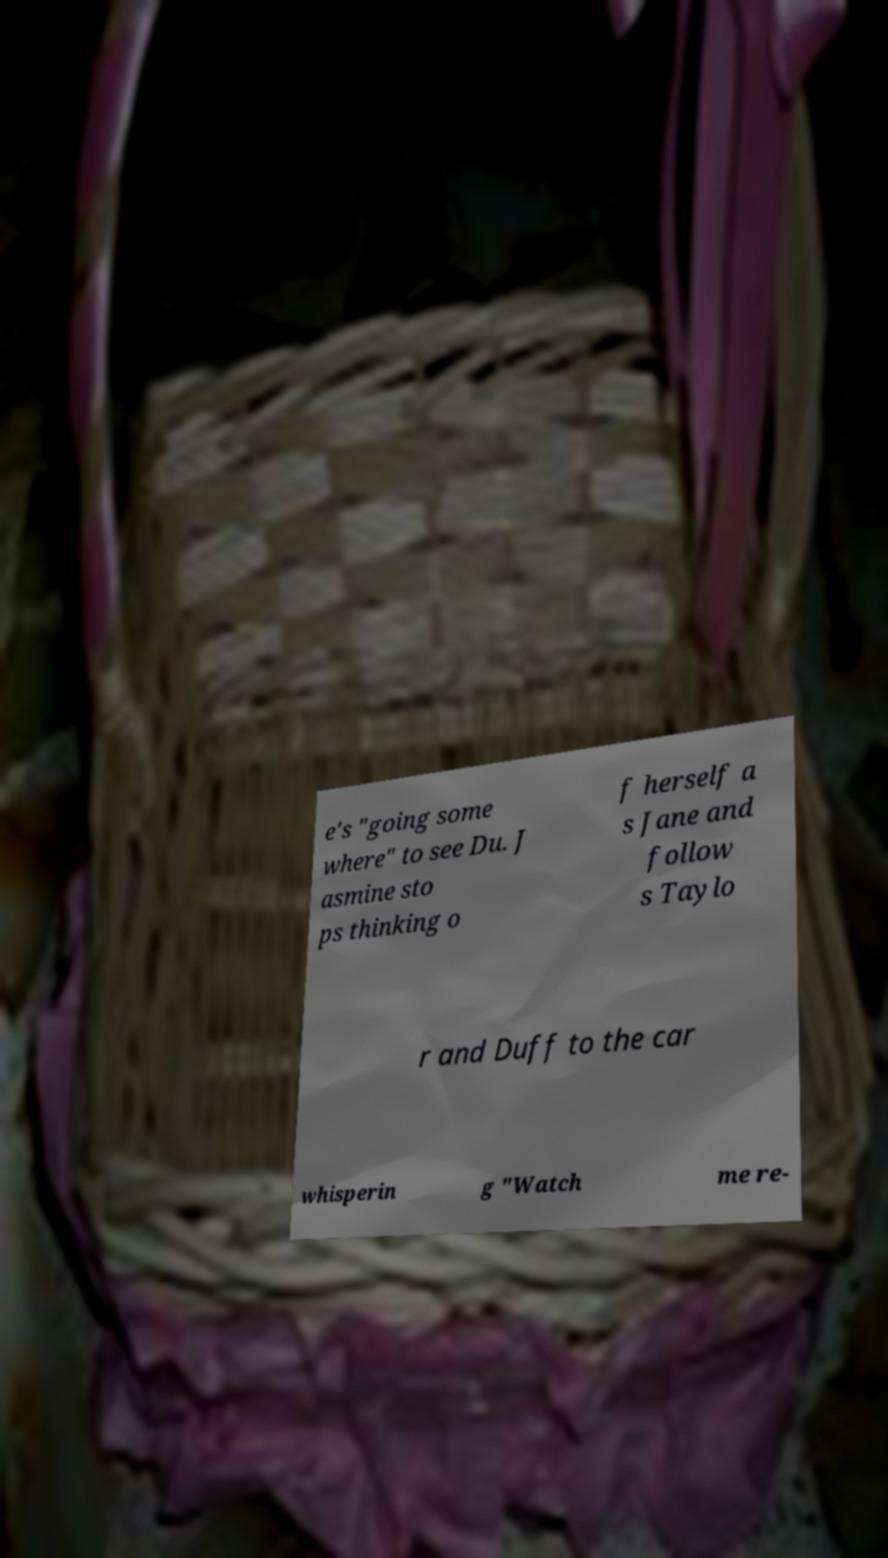Could you extract and type out the text from this image? e's "going some where" to see Du. J asmine sto ps thinking o f herself a s Jane and follow s Taylo r and Duff to the car whisperin g "Watch me re- 